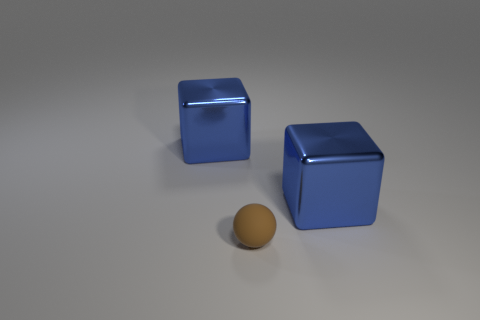Is there any other thing that has the same material as the tiny brown ball?
Provide a short and direct response. No. How many other objects are the same shape as the small brown object?
Offer a very short reply. 0. What number of cylinders are tiny brown things or big blue metallic things?
Make the answer very short. 0. There is a tiny brown ball that is to the left of the blue metallic cube that is right of the tiny brown thing; are there any brown matte spheres that are in front of it?
Offer a terse response. No. What number of gray objects are large spheres or tiny objects?
Offer a very short reply. 0. There is a cube in front of the block to the left of the tiny object; what is it made of?
Provide a short and direct response. Metal. Are there any small metal cubes of the same color as the rubber thing?
Offer a very short reply. No. Is there a big yellow matte sphere?
Offer a very short reply. No. Is the big blue thing to the right of the tiny brown rubber ball made of the same material as the brown sphere?
Your response must be concise. No. What number of blue things have the same size as the brown object?
Provide a succinct answer. 0. 